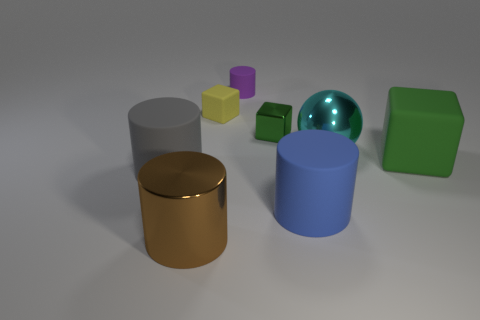Subtract all green cylinders. Subtract all yellow blocks. How many cylinders are left? 4 Add 1 large cubes. How many objects exist? 9 Subtract all balls. How many objects are left? 7 Add 7 blue cylinders. How many blue cylinders are left? 8 Add 5 large purple shiny cubes. How many large purple shiny cubes exist? 5 Subtract 0 purple cubes. How many objects are left? 8 Subtract all shiny cylinders. Subtract all small rubber objects. How many objects are left? 5 